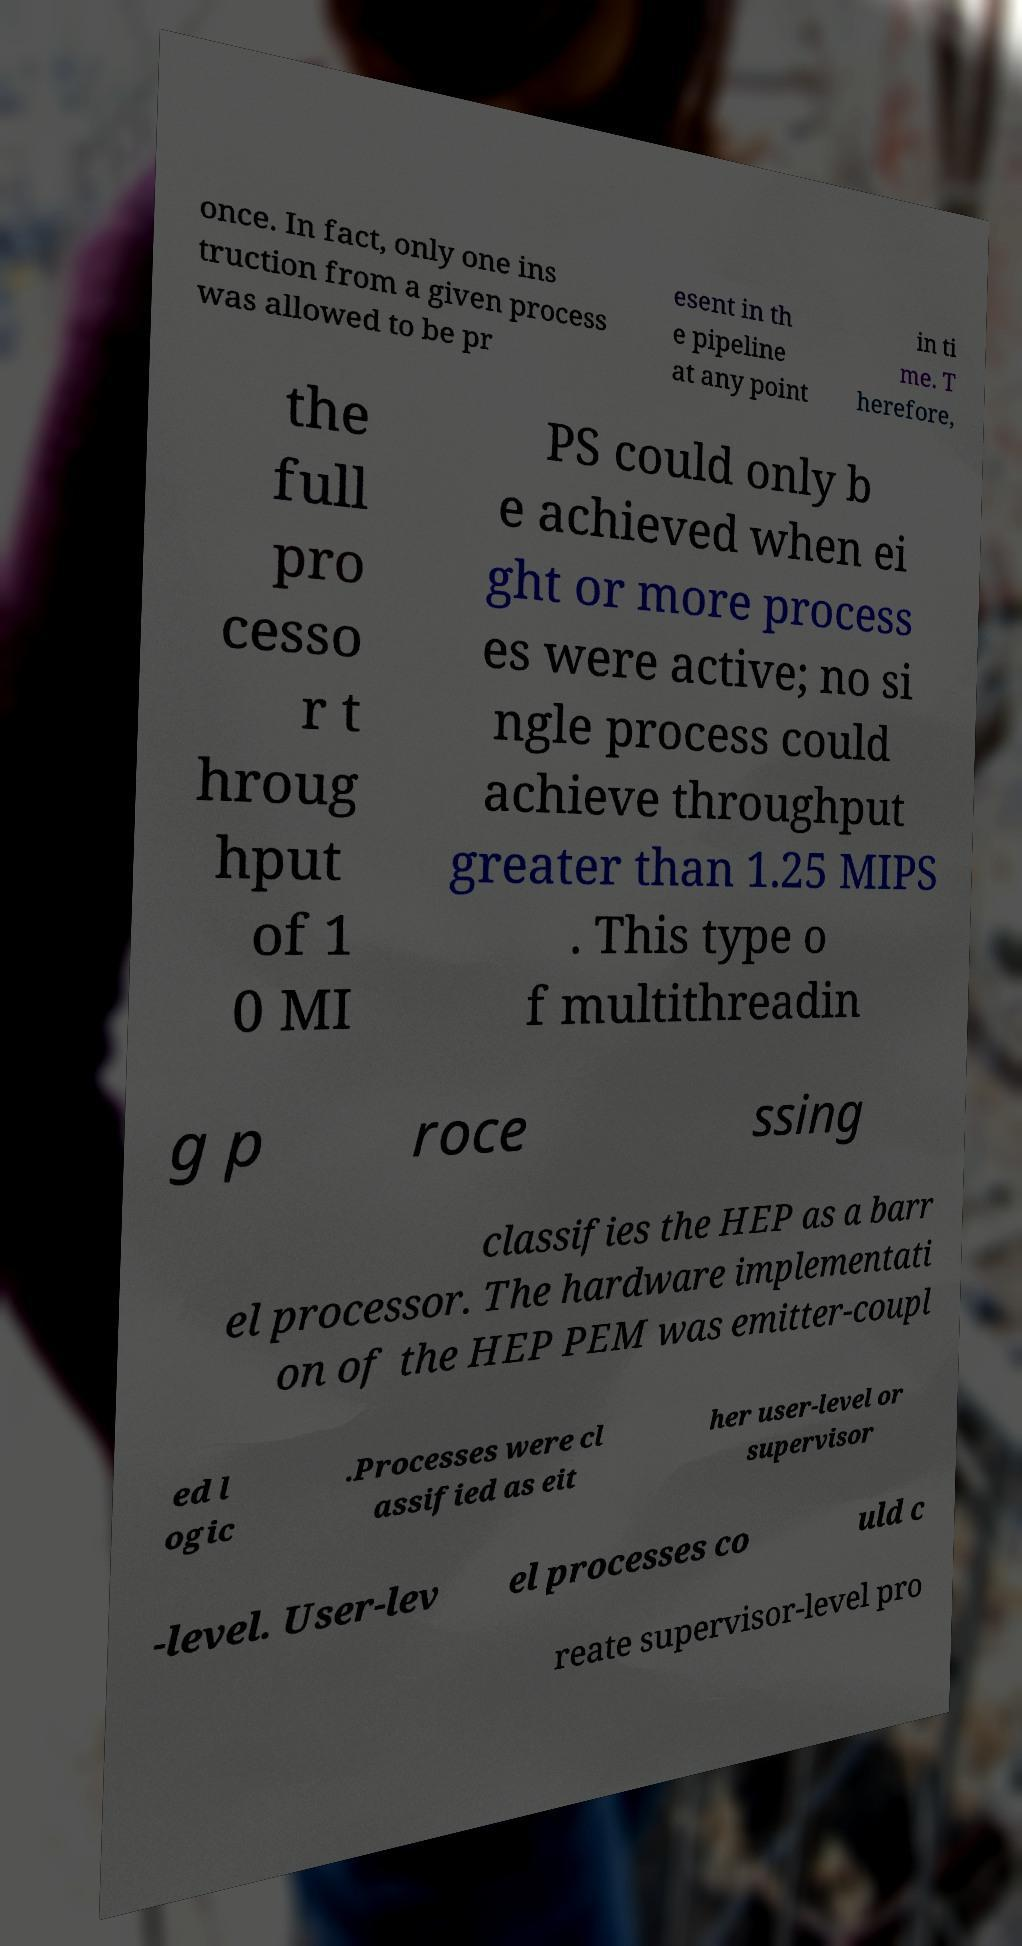What messages or text are displayed in this image? I need them in a readable, typed format. once. In fact, only one ins truction from a given process was allowed to be pr esent in th e pipeline at any point in ti me. T herefore, the full pro cesso r t hroug hput of 1 0 MI PS could only b e achieved when ei ght or more process es were active; no si ngle process could achieve throughput greater than 1.25 MIPS . This type o f multithreadin g p roce ssing classifies the HEP as a barr el processor. The hardware implementati on of the HEP PEM was emitter-coupl ed l ogic .Processes were cl assified as eit her user-level or supervisor -level. User-lev el processes co uld c reate supervisor-level pro 